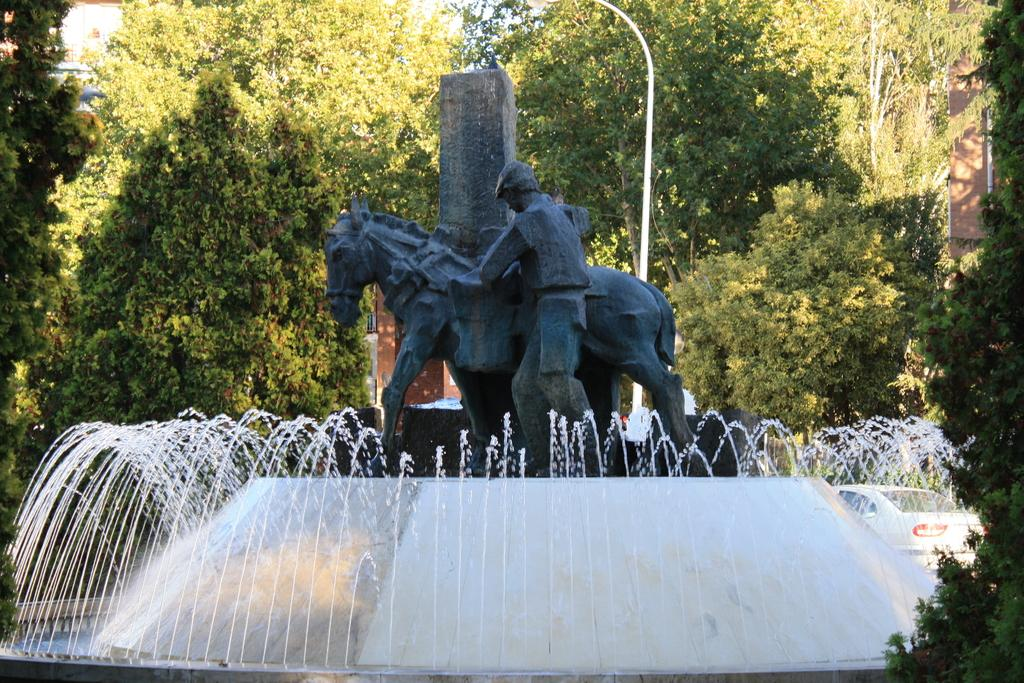What is the main subject in the image? There is a statue in the image. What is the statue positioned near? The statue is between a fountain. What can be seen in the background of the image? There are trees, a pole, and a building in the background of the image. What type of question is the farmer asking the statue in the image? There is no farmer or question present in the image; it features a statue between a fountain with trees, a pole, and a building in the background. 